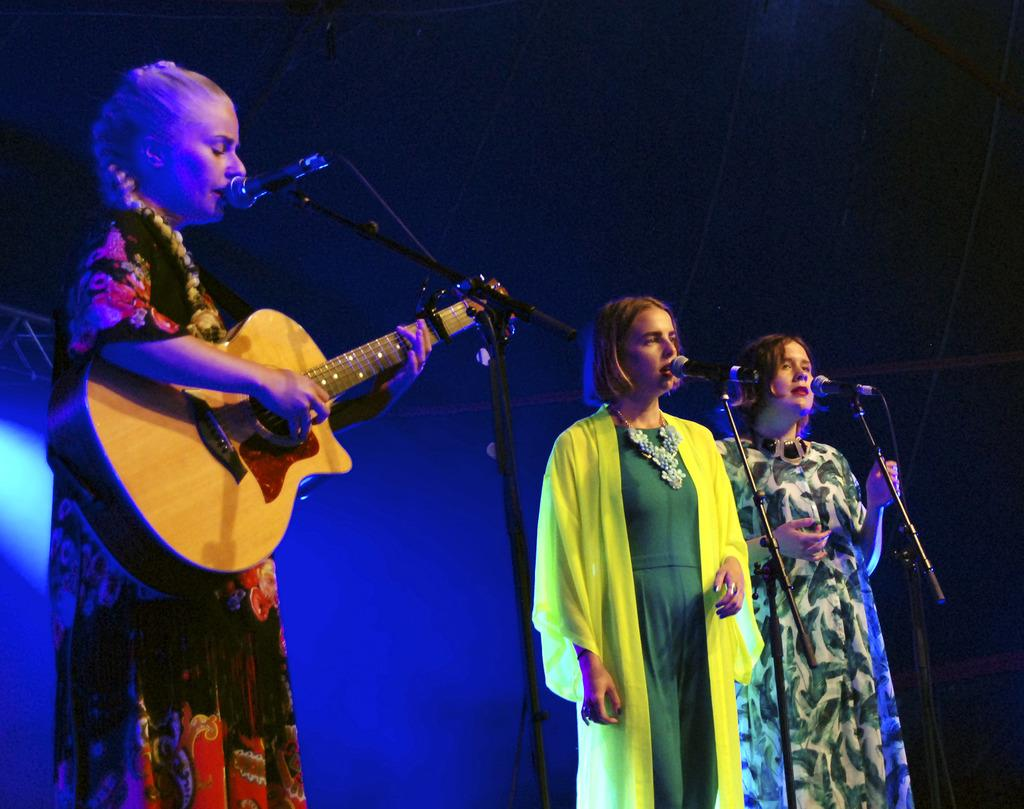How many women are in the image? There are three women in the image. What are the women doing in the image? One of the women is holding a microphone, and another is holding a guitar. What can be seen in the background of the image? There is a light visible in the background of the image. What type of doll is the secretary using to answer questions in the image? There is no doll or secretary present in the image. 